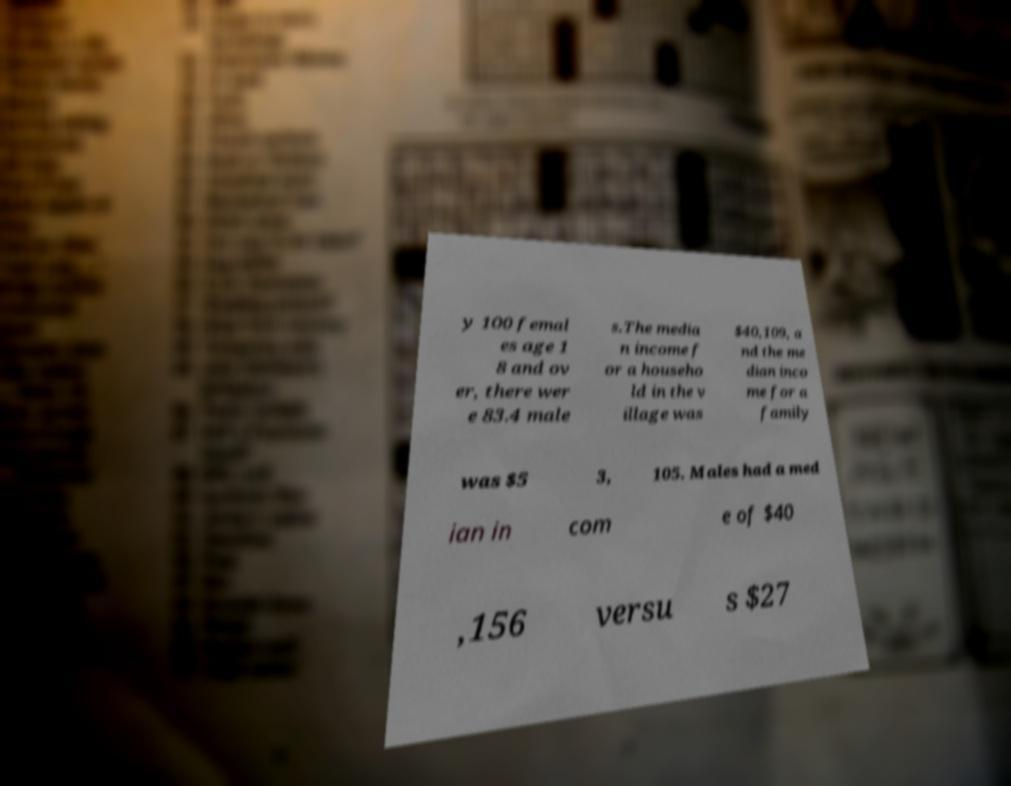What messages or text are displayed in this image? I need them in a readable, typed format. y 100 femal es age 1 8 and ov er, there wer e 83.4 male s.The media n income f or a househo ld in the v illage was $40,109, a nd the me dian inco me for a family was $5 3, 105. Males had a med ian in com e of $40 ,156 versu s $27 